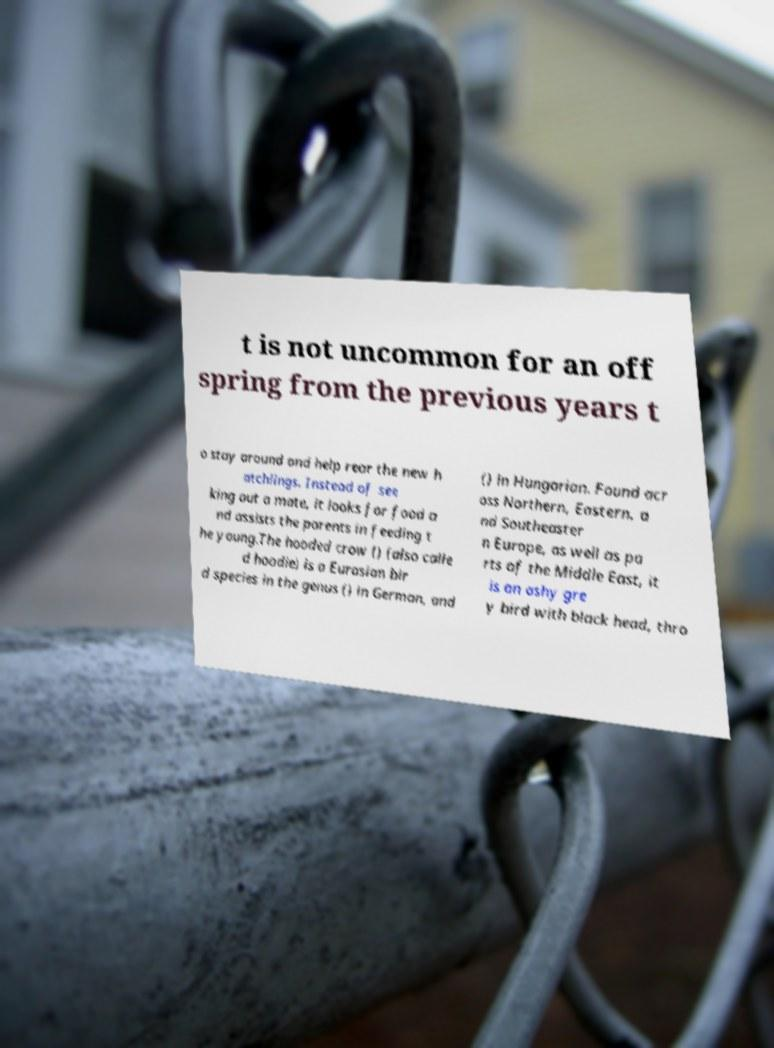Could you extract and type out the text from this image? t is not uncommon for an off spring from the previous years t o stay around and help rear the new h atchlings. Instead of see king out a mate, it looks for food a nd assists the parents in feeding t he young.The hooded crow () (also calle d hoodie) is a Eurasian bir d species in the genus () in German, and () in Hungarian. Found acr oss Northern, Eastern, a nd Southeaster n Europe, as well as pa rts of the Middle East, it is an ashy gre y bird with black head, thro 